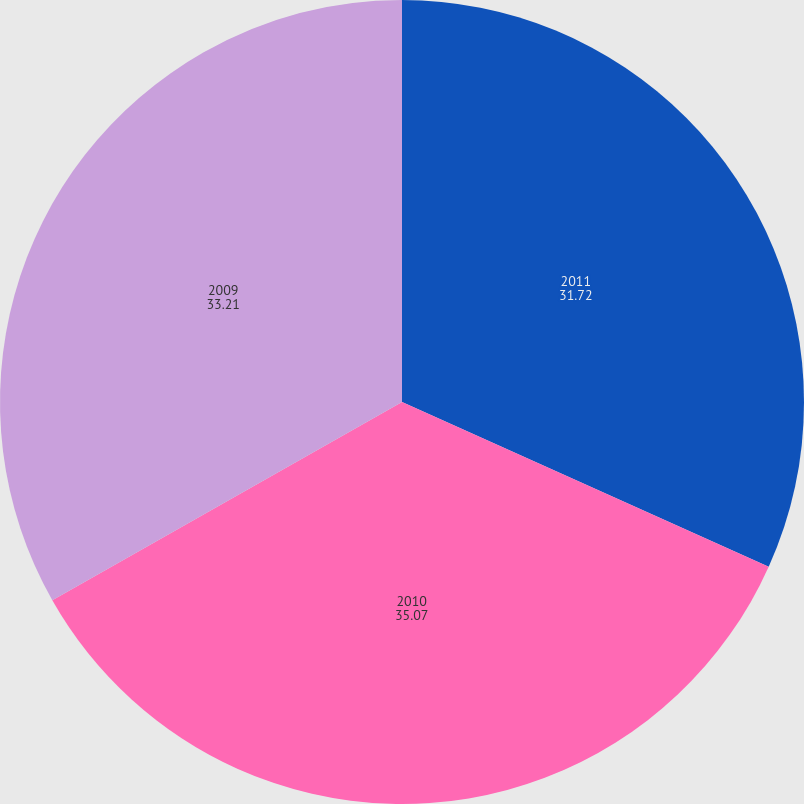<chart> <loc_0><loc_0><loc_500><loc_500><pie_chart><fcel>2011<fcel>2010<fcel>2009<nl><fcel>31.72%<fcel>35.07%<fcel>33.21%<nl></chart> 